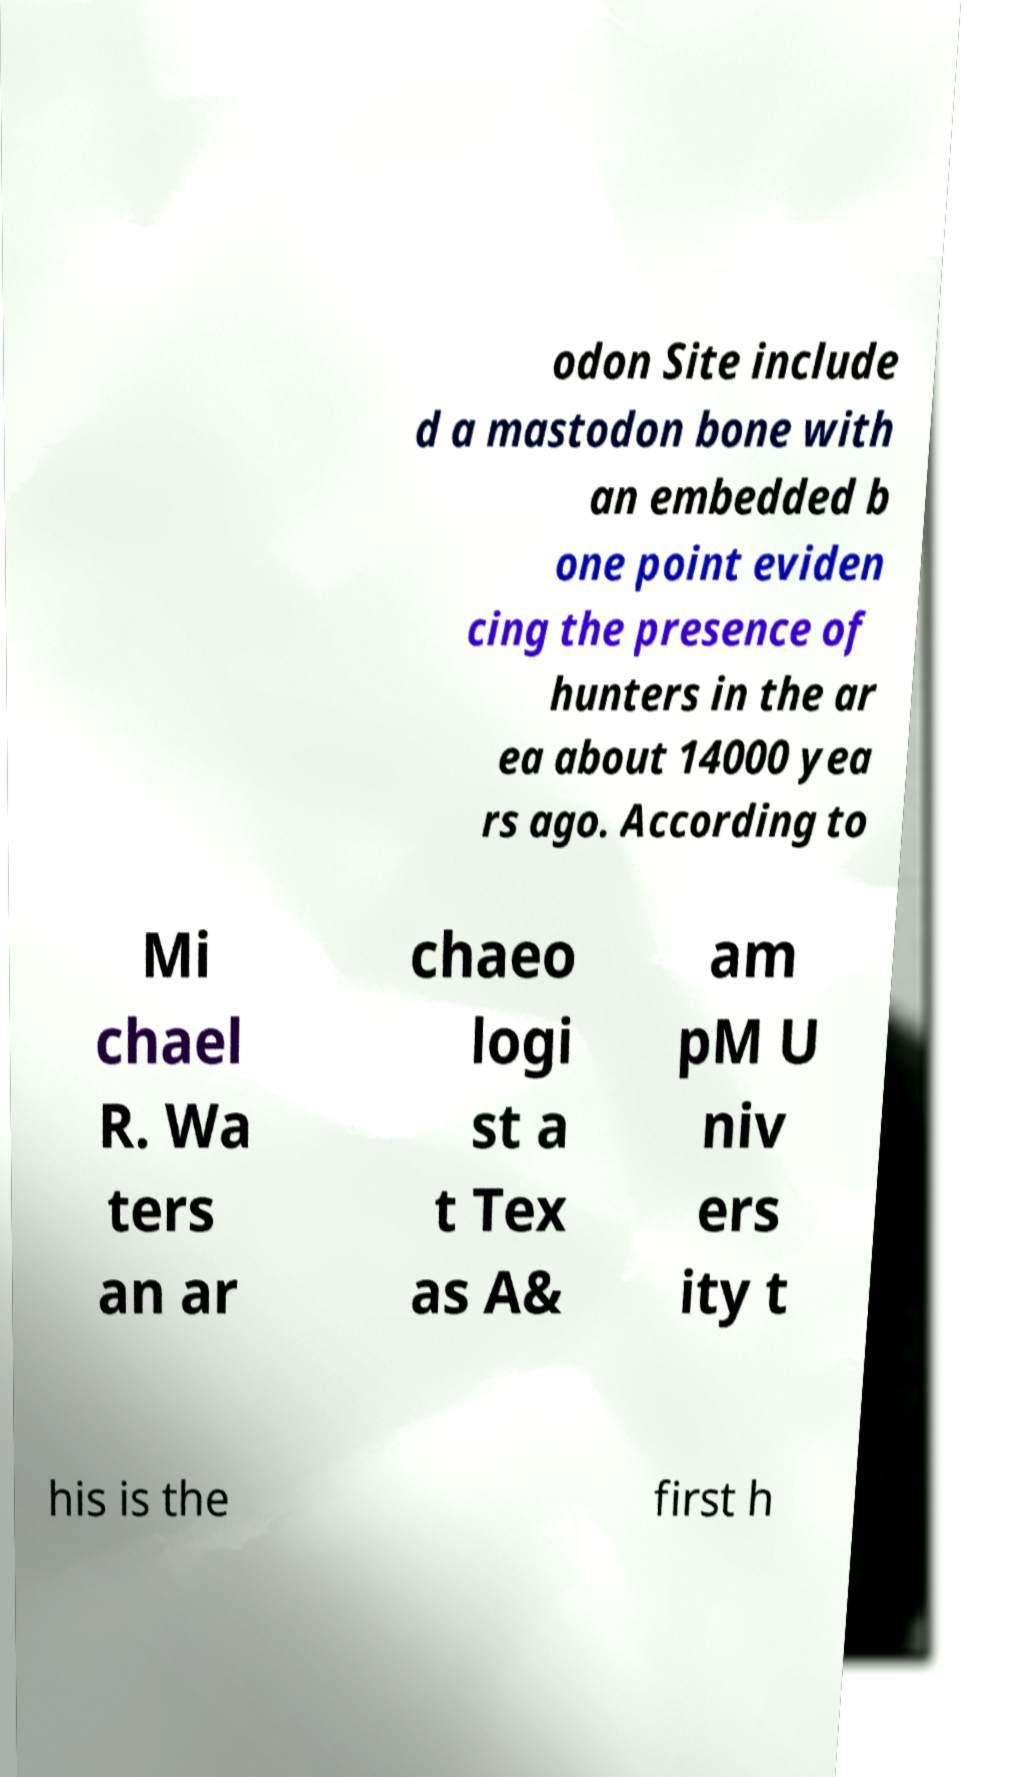Please read and relay the text visible in this image. What does it say? odon Site include d a mastodon bone with an embedded b one point eviden cing the presence of hunters in the ar ea about 14000 yea rs ago. According to Mi chael R. Wa ters an ar chaeo logi st a t Tex as A& am pM U niv ers ity t his is the first h 